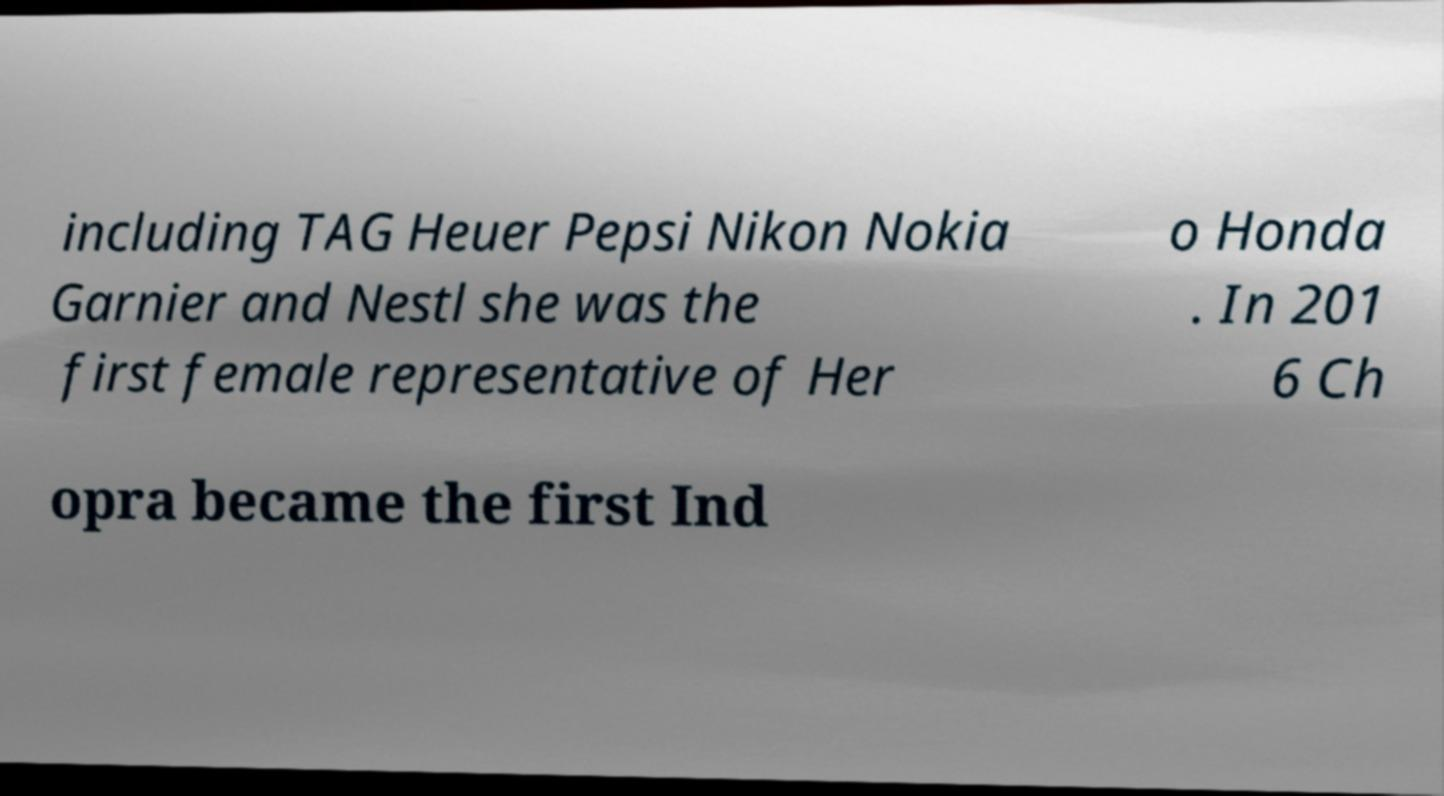Could you extract and type out the text from this image? including TAG Heuer Pepsi Nikon Nokia Garnier and Nestl she was the first female representative of Her o Honda . In 201 6 Ch opra became the first Ind 